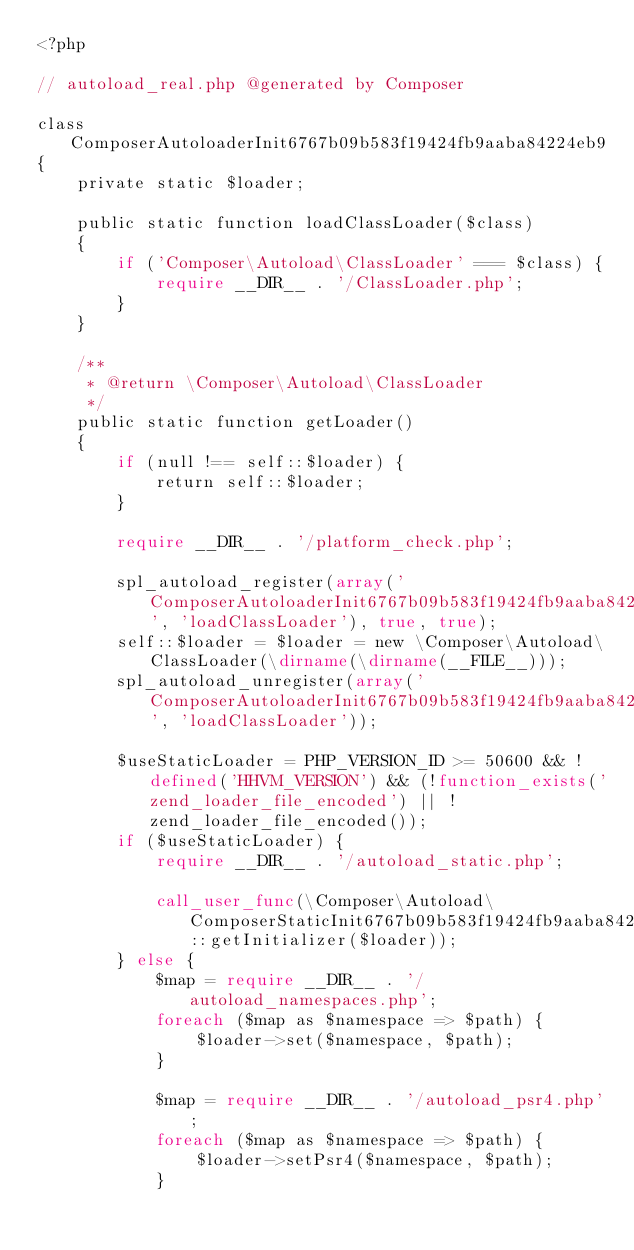<code> <loc_0><loc_0><loc_500><loc_500><_PHP_><?php

// autoload_real.php @generated by Composer

class ComposerAutoloaderInit6767b09b583f19424fb9aaba84224eb9
{
    private static $loader;

    public static function loadClassLoader($class)
    {
        if ('Composer\Autoload\ClassLoader' === $class) {
            require __DIR__ . '/ClassLoader.php';
        }
    }

    /**
     * @return \Composer\Autoload\ClassLoader
     */
    public static function getLoader()
    {
        if (null !== self::$loader) {
            return self::$loader;
        }

        require __DIR__ . '/platform_check.php';

        spl_autoload_register(array('ComposerAutoloaderInit6767b09b583f19424fb9aaba84224eb9', 'loadClassLoader'), true, true);
        self::$loader = $loader = new \Composer\Autoload\ClassLoader(\dirname(\dirname(__FILE__)));
        spl_autoload_unregister(array('ComposerAutoloaderInit6767b09b583f19424fb9aaba84224eb9', 'loadClassLoader'));

        $useStaticLoader = PHP_VERSION_ID >= 50600 && !defined('HHVM_VERSION') && (!function_exists('zend_loader_file_encoded') || !zend_loader_file_encoded());
        if ($useStaticLoader) {
            require __DIR__ . '/autoload_static.php';

            call_user_func(\Composer\Autoload\ComposerStaticInit6767b09b583f19424fb9aaba84224eb9::getInitializer($loader));
        } else {
            $map = require __DIR__ . '/autoload_namespaces.php';
            foreach ($map as $namespace => $path) {
                $loader->set($namespace, $path);
            }

            $map = require __DIR__ . '/autoload_psr4.php';
            foreach ($map as $namespace => $path) {
                $loader->setPsr4($namespace, $path);
            }
</code> 